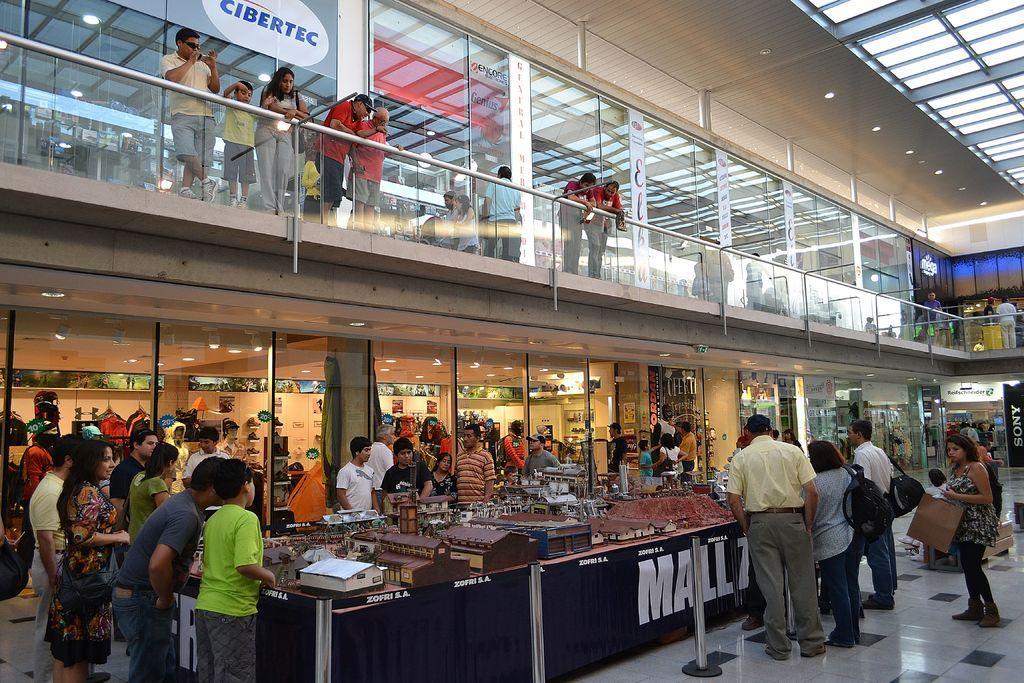Describe this image in one or two sentences. In this picture I can see inside of the shopping mall, in which we can see so many shops and also we can see few people around, on the app store we can see few people standing and watching. 